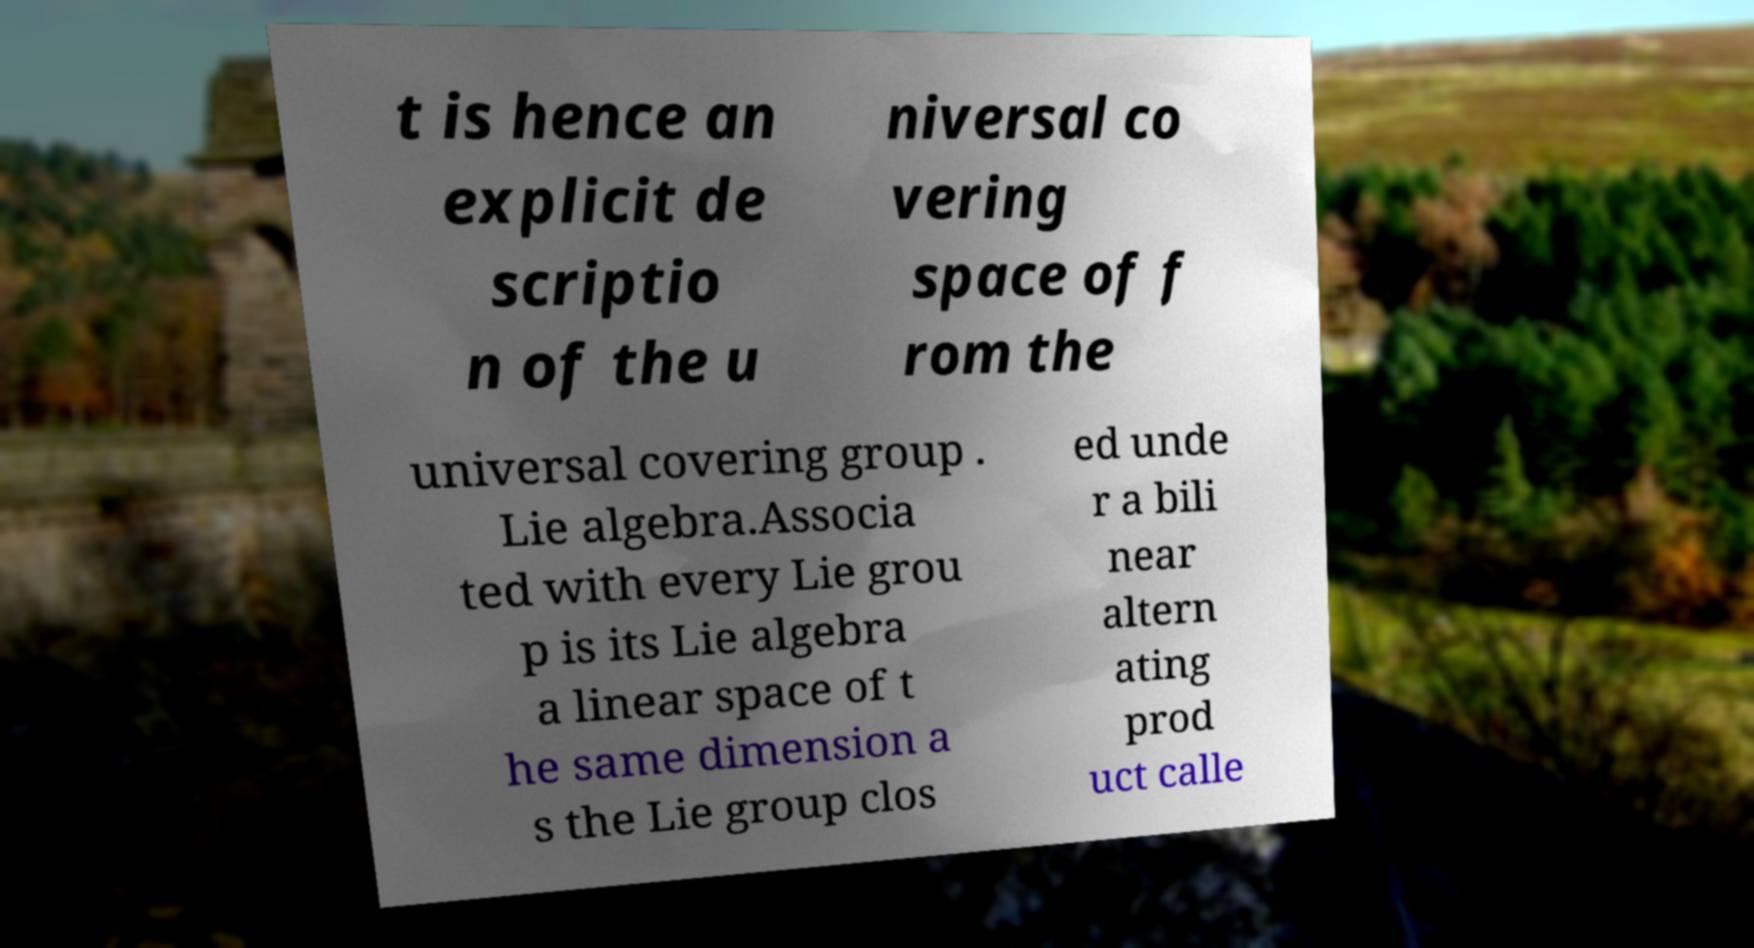Can you read and provide the text displayed in the image?This photo seems to have some interesting text. Can you extract and type it out for me? t is hence an explicit de scriptio n of the u niversal co vering space of f rom the universal covering group . Lie algebra.Associa ted with every Lie grou p is its Lie algebra a linear space of t he same dimension a s the Lie group clos ed unde r a bili near altern ating prod uct calle 